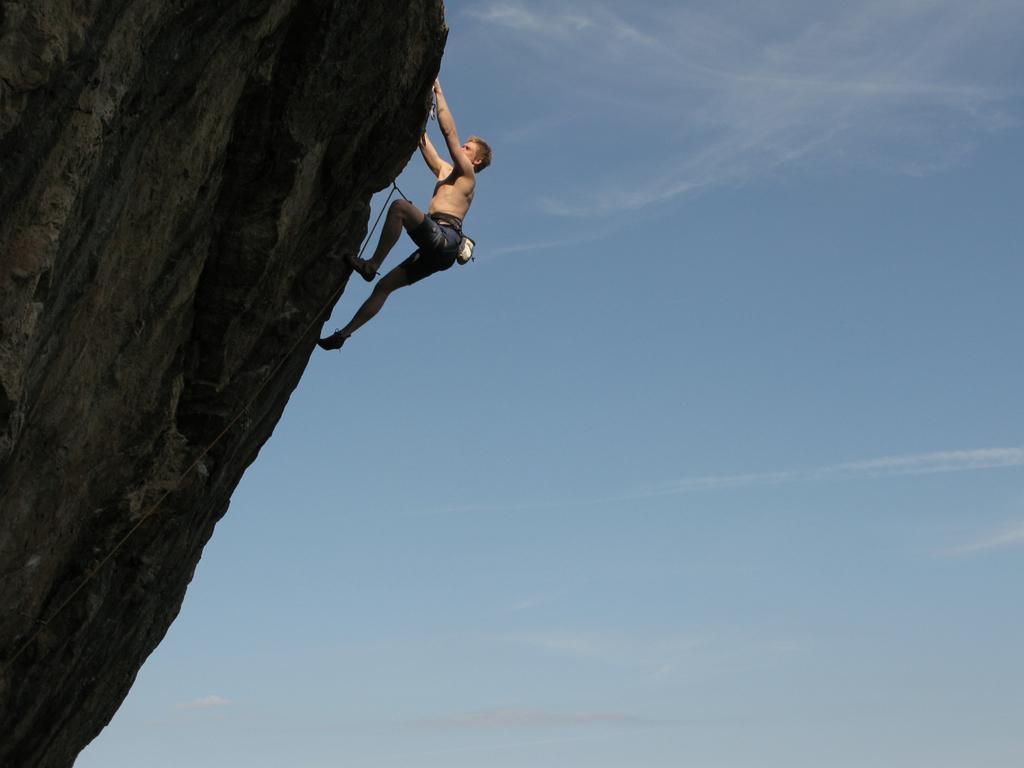Could you give a brief overview of what you see in this image? In this image there is the sky, there is a mountain towards the left of the image, there is a man climbing a mountain, there is a rope. 